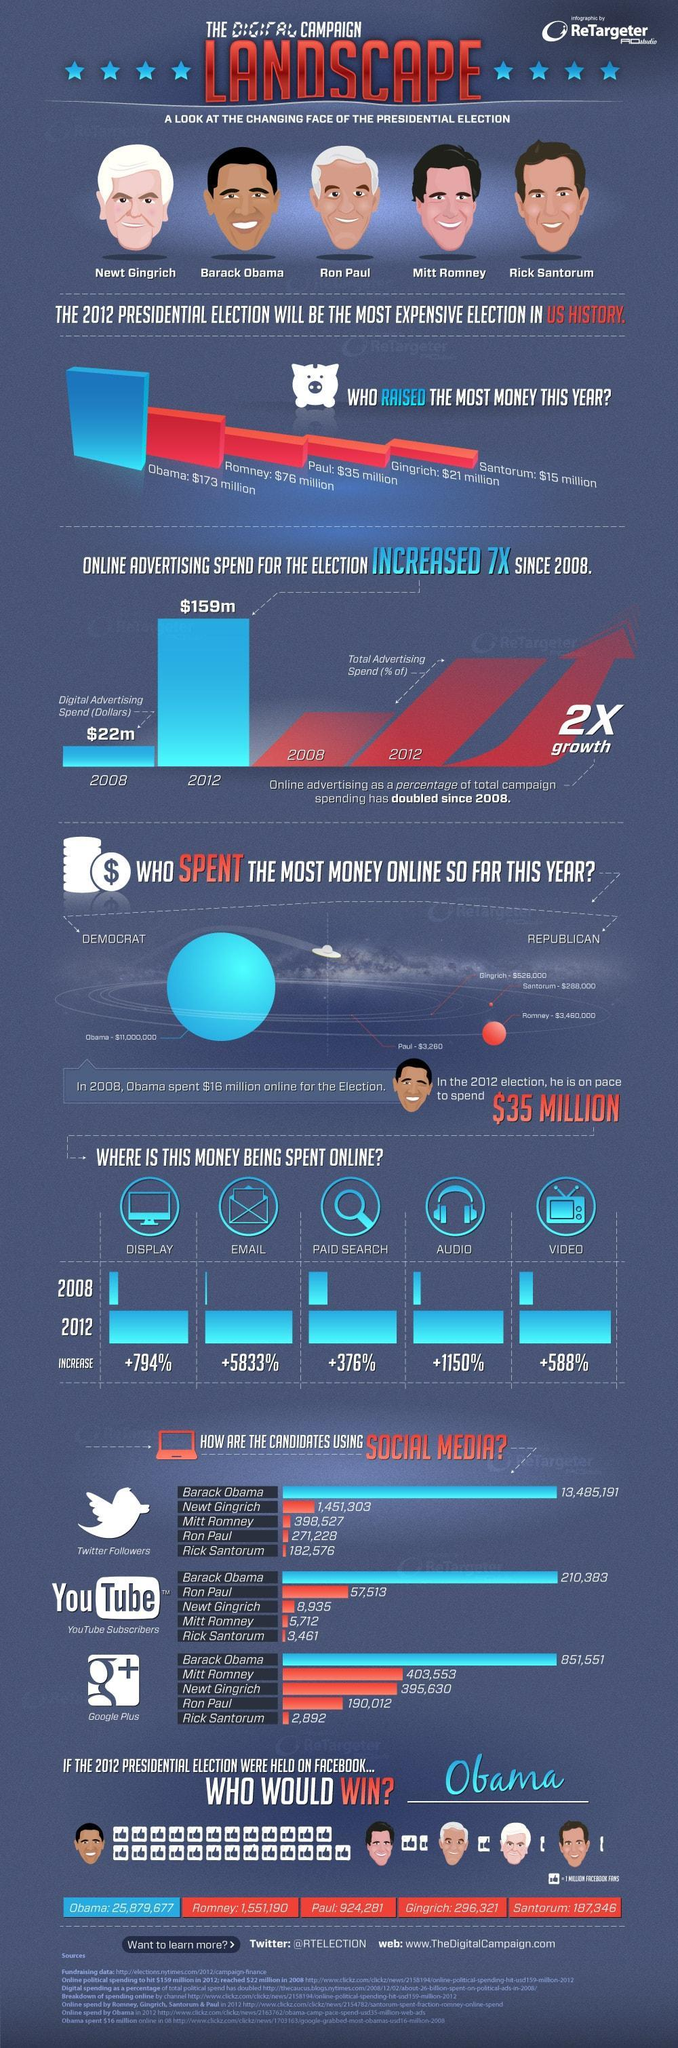How many presidential candidates are shown here?
Answer the question with a short phrase. 5 How many facebook likes would Mitt Romney get if election was to be held on Facebook? 1,551,190 How many sources are listed at the bottom? 7 Who raised the biggest amount of money in 2012 for the election? Obama Which candidate has the most number of followers in all three- Twitter, Youtube and Google Plus? Obama By what amount did Romney raise more money than Paul for the 2012 election? $41 million By how what amount has money spent on digital advertising increase from 2008 to 2012? $137m 